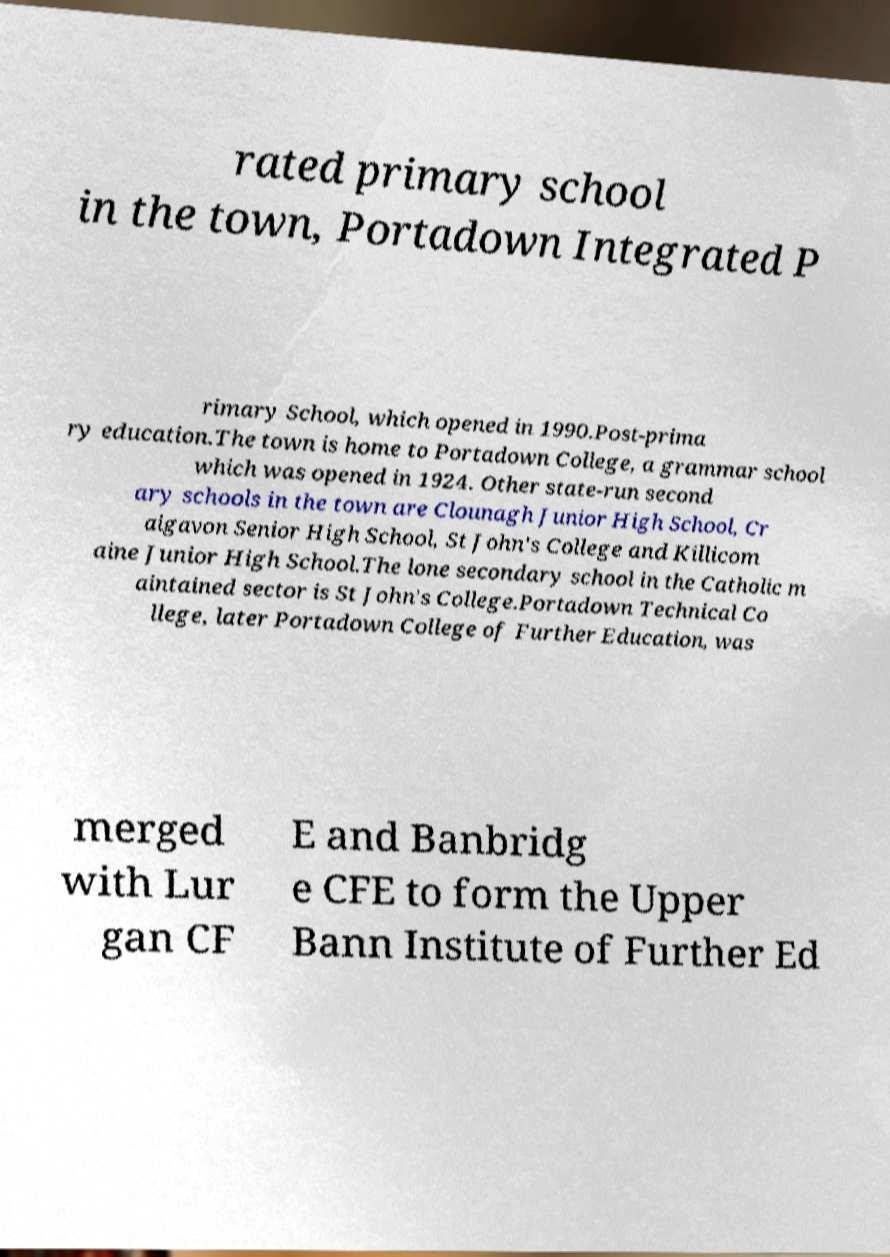For documentation purposes, I need the text within this image transcribed. Could you provide that? rated primary school in the town, Portadown Integrated P rimary School, which opened in 1990.Post-prima ry education.The town is home to Portadown College, a grammar school which was opened in 1924. Other state-run second ary schools in the town are Clounagh Junior High School, Cr aigavon Senior High School, St John's College and Killicom aine Junior High School.The lone secondary school in the Catholic m aintained sector is St John's College.Portadown Technical Co llege, later Portadown College of Further Education, was merged with Lur gan CF E and Banbridg e CFE to form the Upper Bann Institute of Further Ed 